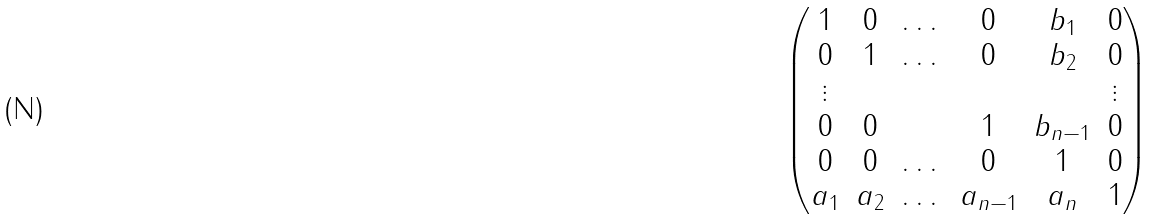Convert formula to latex. <formula><loc_0><loc_0><loc_500><loc_500>\begin{pmatrix} 1 & 0 & \dots & 0 & b _ { 1 } & 0 \\ 0 & 1 & \dots & 0 & b _ { 2 } & 0 \\ \vdots & & & & & \vdots \\ 0 & 0 & & 1 & b _ { n - 1 } & 0 \\ 0 & 0 & \dots & 0 & 1 & 0 \\ a _ { 1 } & a _ { 2 } & \dots & a _ { n - 1 } & a _ { n } & 1 \\ \end{pmatrix}</formula> 